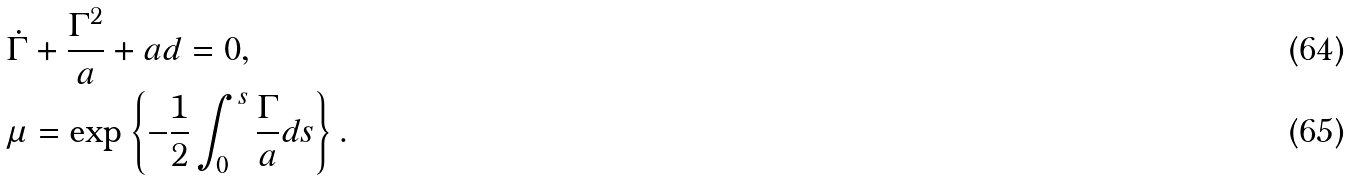Convert formula to latex. <formula><loc_0><loc_0><loc_500><loc_500>& \dot { \Gamma } + \frac { \Gamma ^ { 2 } } { a } + a d = 0 , \\ & \mu = \exp \left \{ - \frac { 1 } { 2 } \int _ { 0 } ^ { s } \frac { \Gamma } { a } d s \right \} .</formula> 